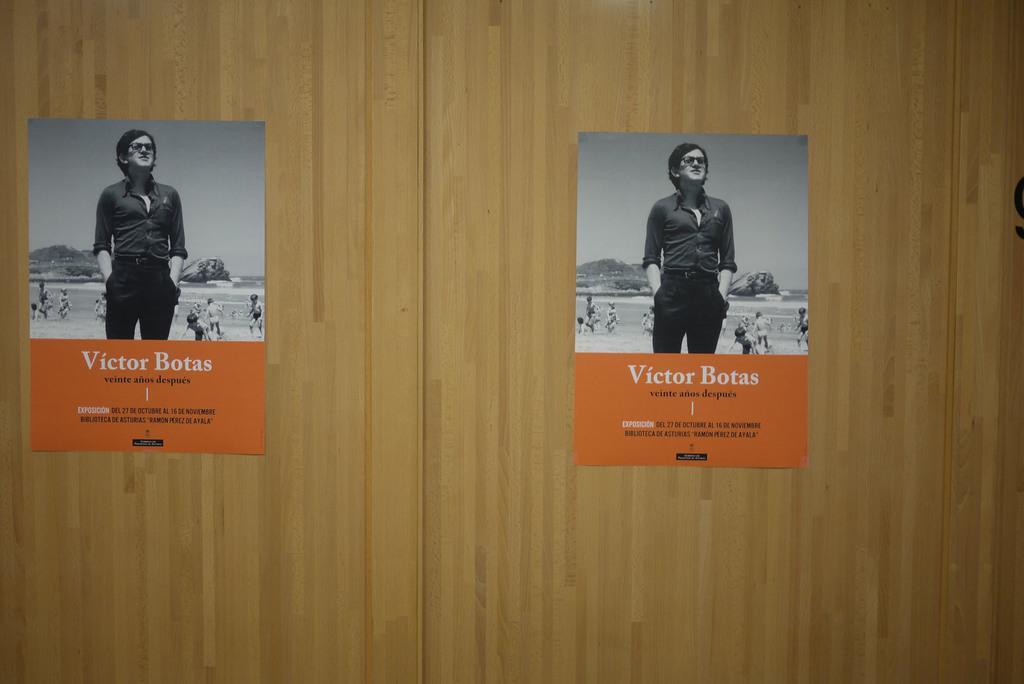Can you describe this image briefly? In this image I can see two same posters to the wooden wall which is in brown color. In the posters I can see the group of people, water, mountain and the sky. I can also see something is written on it. 